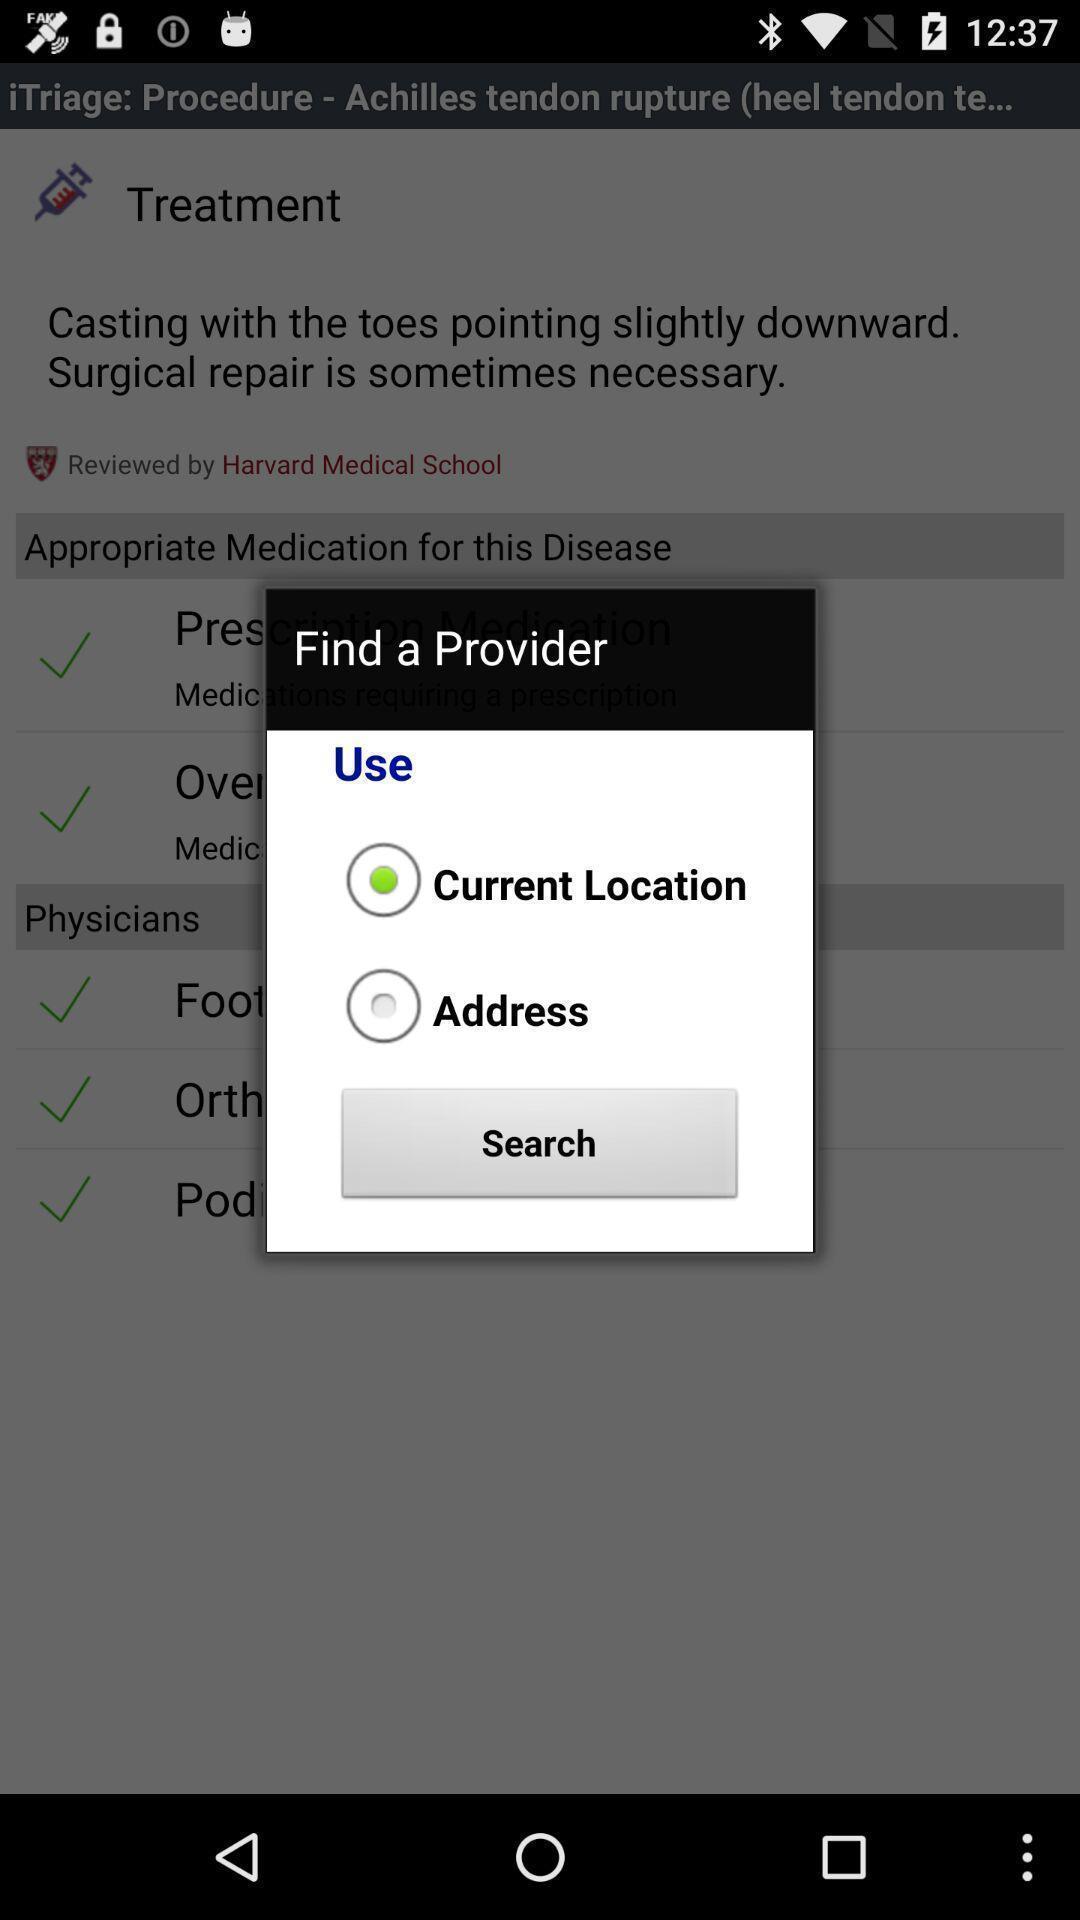Provide a textual representation of this image. Pop-up with options in a medical services app. 